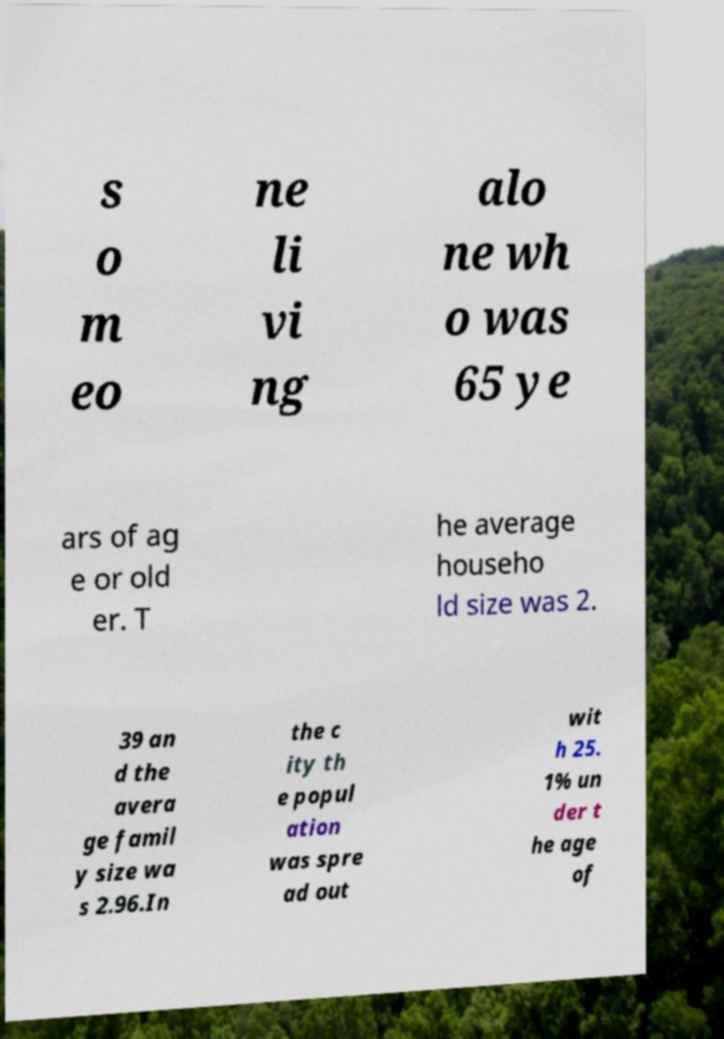Can you accurately transcribe the text from the provided image for me? s o m eo ne li vi ng alo ne wh o was 65 ye ars of ag e or old er. T he average househo ld size was 2. 39 an d the avera ge famil y size wa s 2.96.In the c ity th e popul ation was spre ad out wit h 25. 1% un der t he age of 